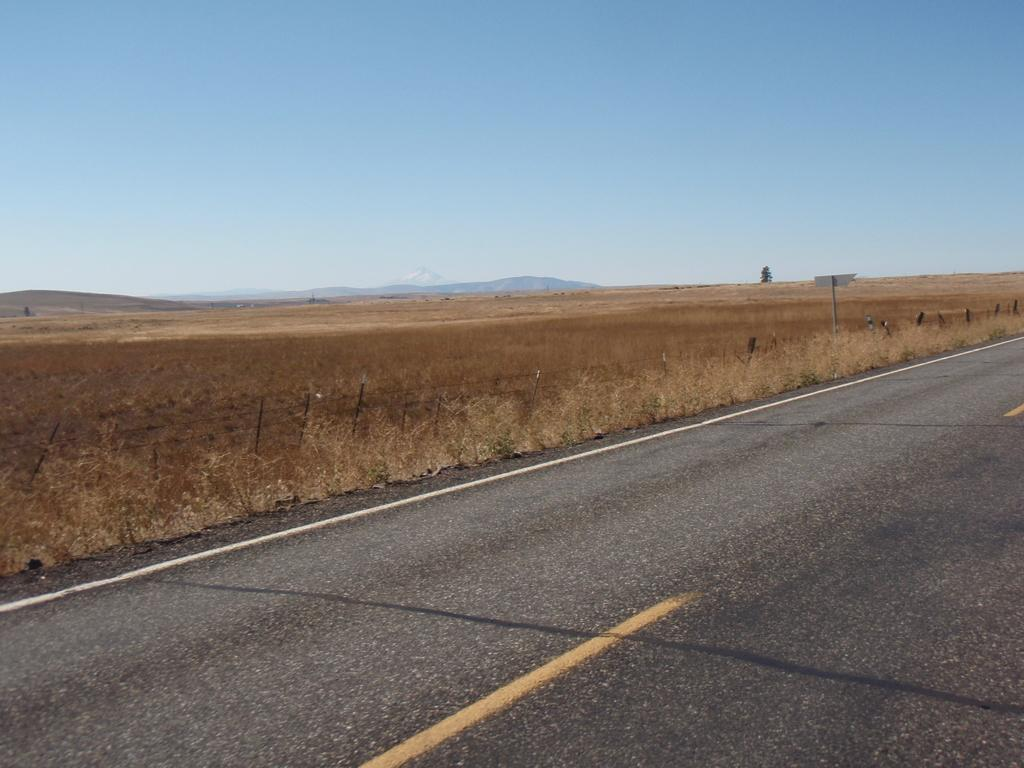What is the main feature of the image? There is a road in the image. What else can be seen alongside the road? There is fencing and plants visible in the image. What is visible in the background of the image? The sky is visible in the background of the image. Can you describe the white object in the image? There is a white color board on a pole in the image. How many rats are sitting on the wheel in the image? There are no rats or wheels present in the image. How many passengers are visible in the image? There is no indication of passengers in the image; it features a road, fencing, plants, sky, and a white color board on a pole. 